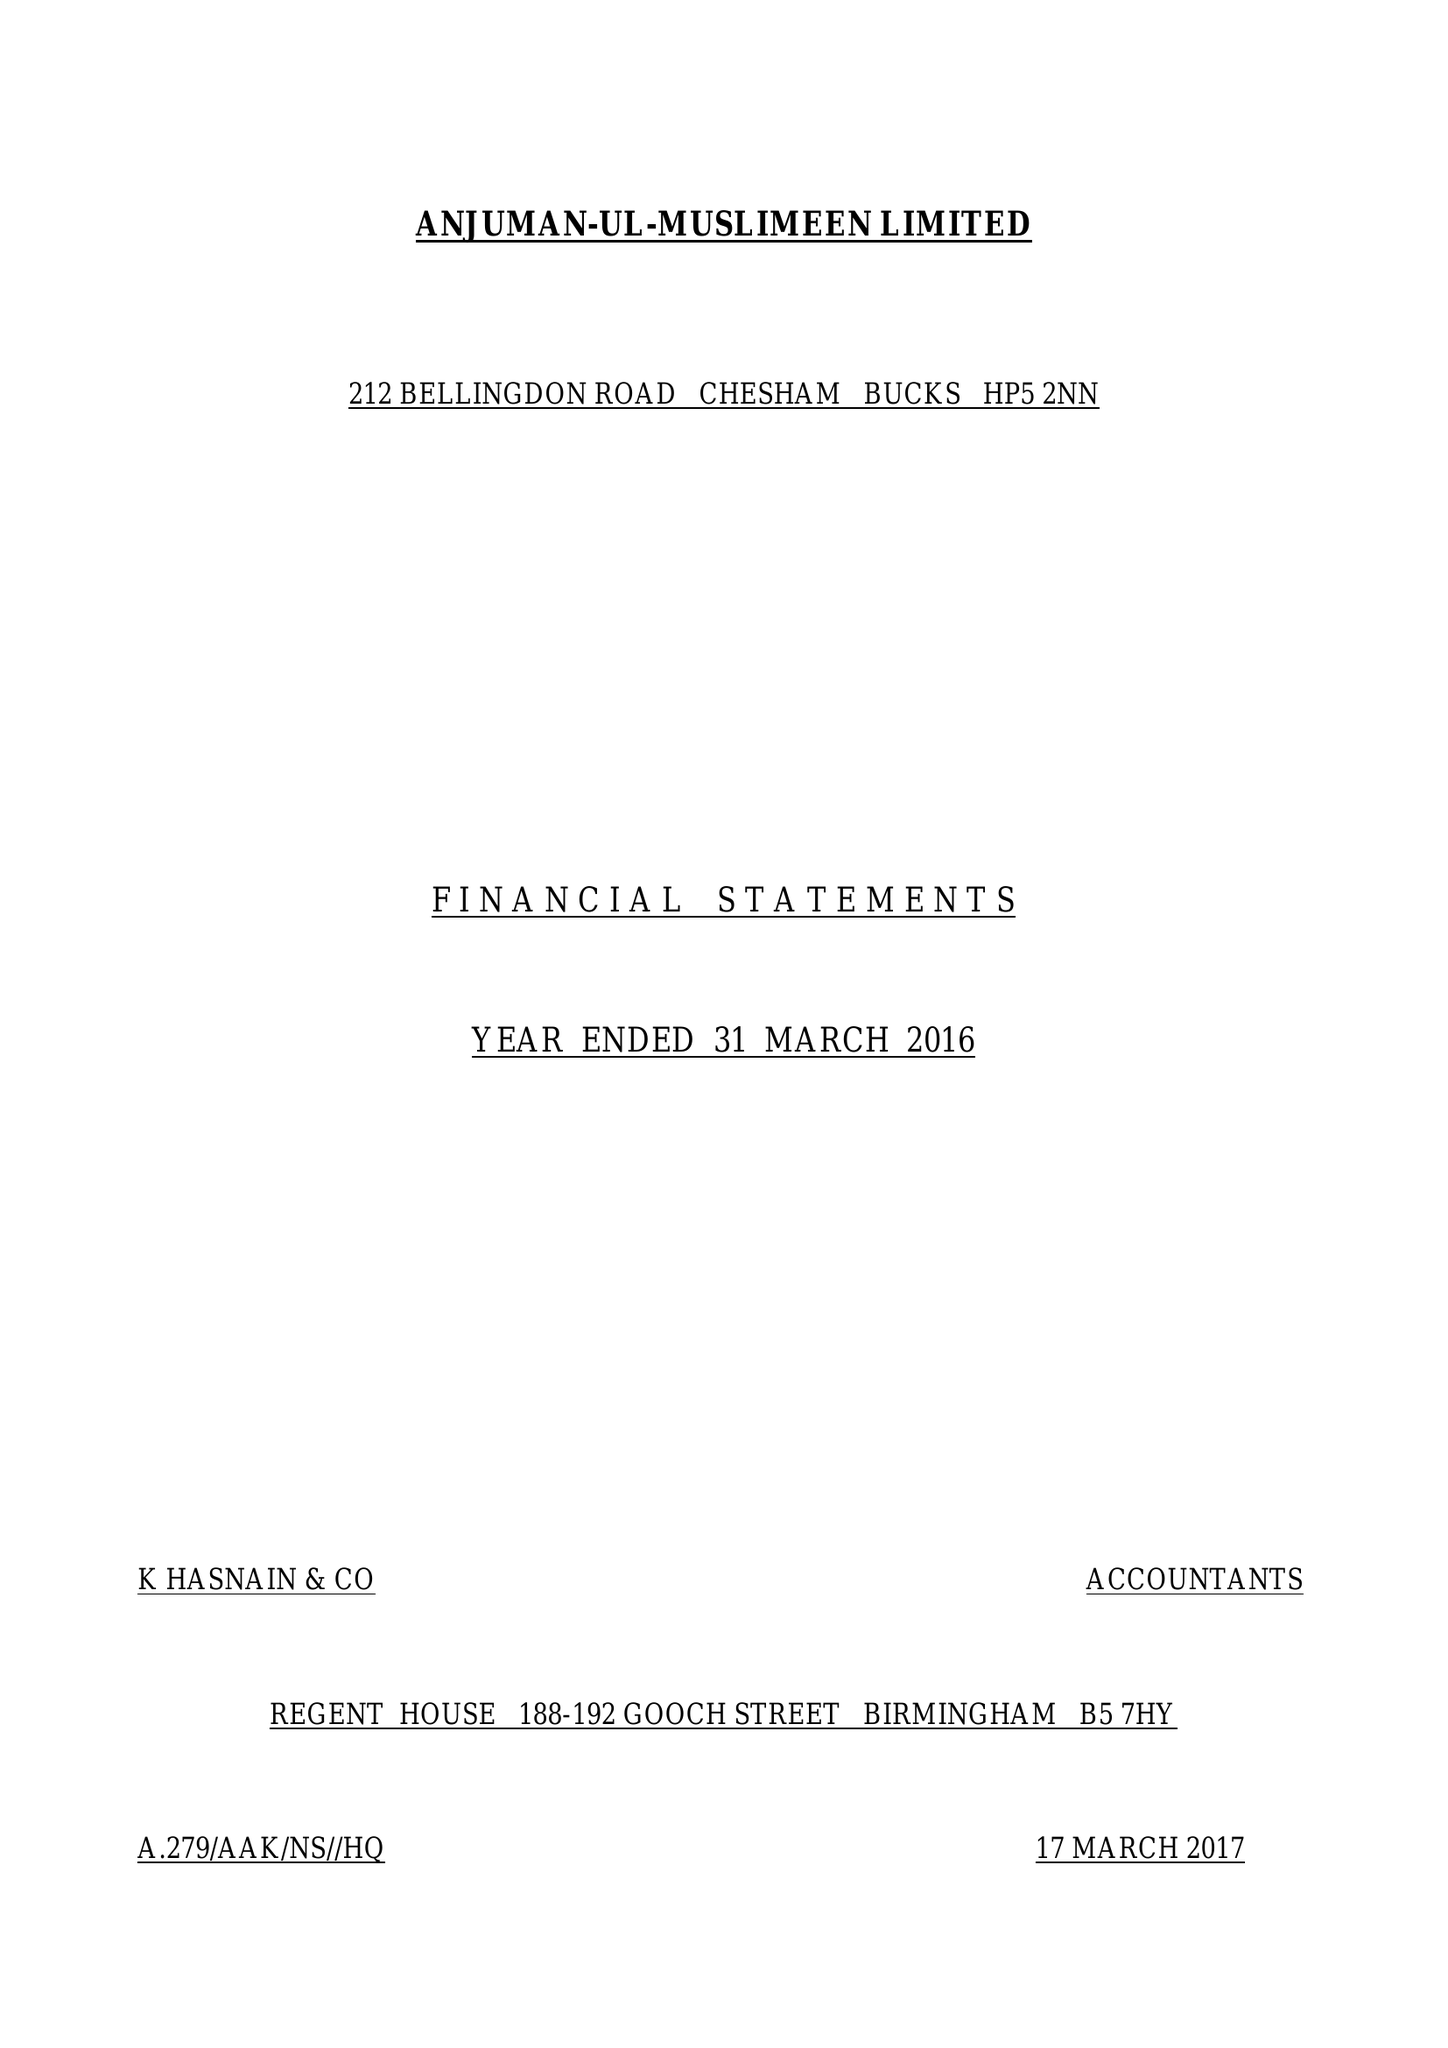What is the value for the address__post_town?
Answer the question using a single word or phrase. CHESHAM 